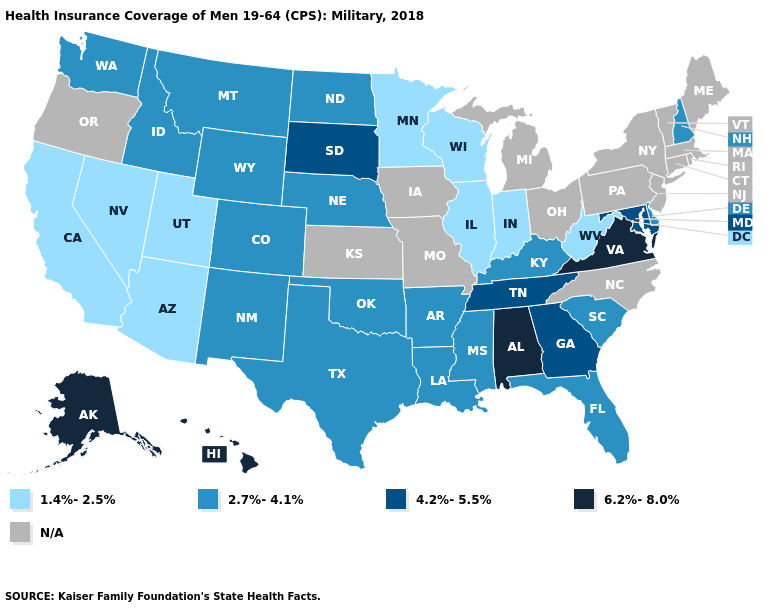What is the value of Alaska?
Give a very brief answer. 6.2%-8.0%. Name the states that have a value in the range 4.2%-5.5%?
Keep it brief. Georgia, Maryland, South Dakota, Tennessee. What is the lowest value in the USA?
Give a very brief answer. 1.4%-2.5%. Name the states that have a value in the range N/A?
Answer briefly. Connecticut, Iowa, Kansas, Maine, Massachusetts, Michigan, Missouri, New Jersey, New York, North Carolina, Ohio, Oregon, Pennsylvania, Rhode Island, Vermont. Which states hav the highest value in the West?
Quick response, please. Alaska, Hawaii. What is the value of Missouri?
Be succinct. N/A. Does Minnesota have the lowest value in the MidWest?
Concise answer only. Yes. Is the legend a continuous bar?
Quick response, please. No. What is the value of Ohio?
Concise answer only. N/A. What is the highest value in states that border Idaho?
Answer briefly. 2.7%-4.1%. What is the value of North Dakota?
Give a very brief answer. 2.7%-4.1%. 